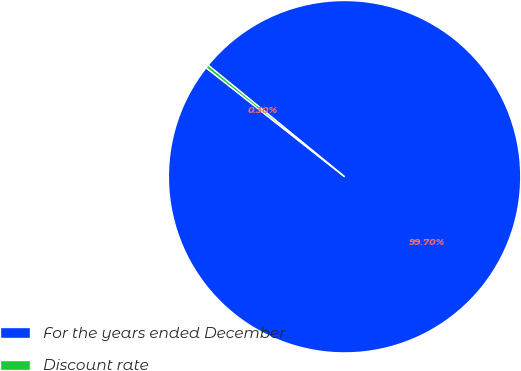Convert chart to OTSL. <chart><loc_0><loc_0><loc_500><loc_500><pie_chart><fcel>For the years ended December<fcel>Discount rate<nl><fcel>99.7%<fcel>0.3%<nl></chart> 